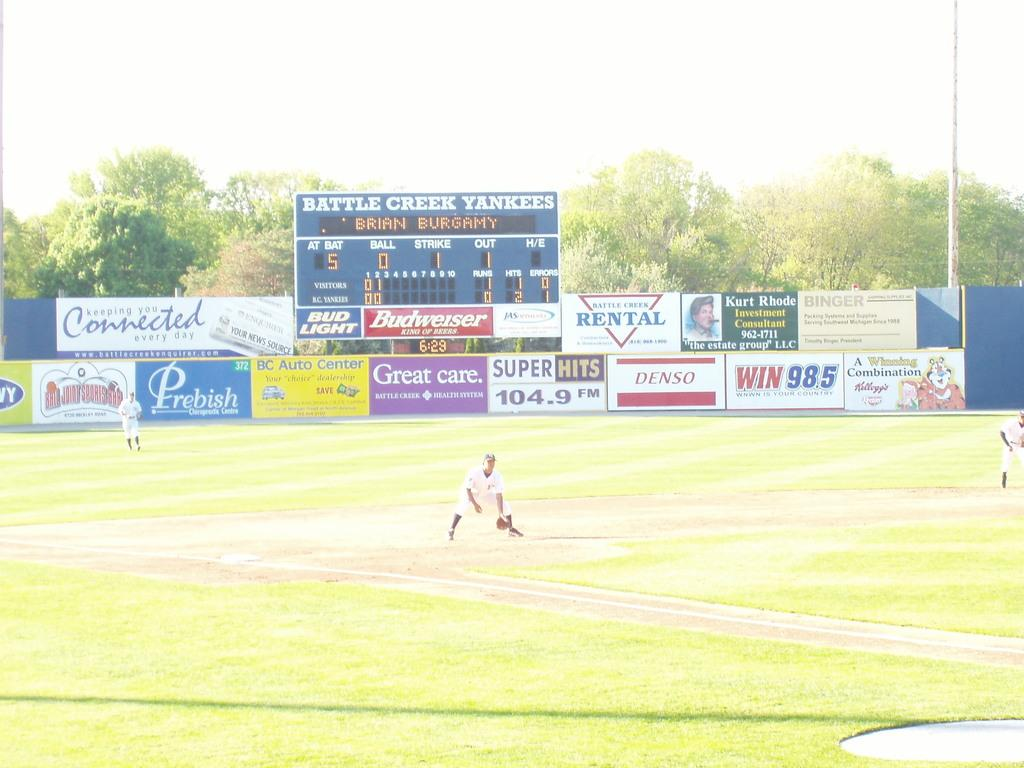<image>
Offer a succinct explanation of the picture presented. Baseball field with sponsors names and ads on a wall 